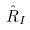Convert formula to latex. <formula><loc_0><loc_0><loc_500><loc_500>\hat { R } _ { I }</formula> 